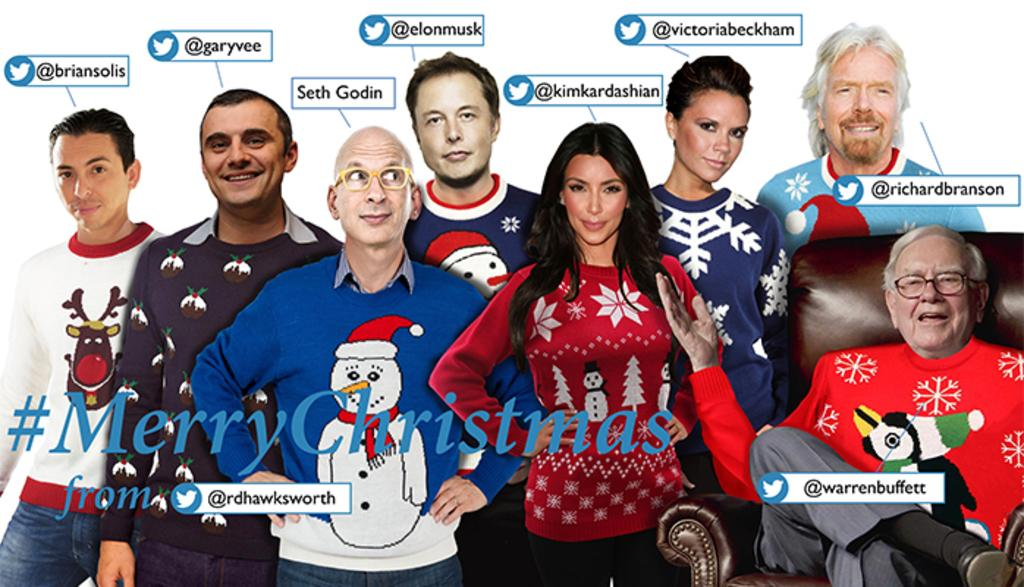<image>
Write a terse but informative summary of the picture. A group of people are wearing ugly Christmas sweaters with the hashtag of MerryChistmas across the front. 